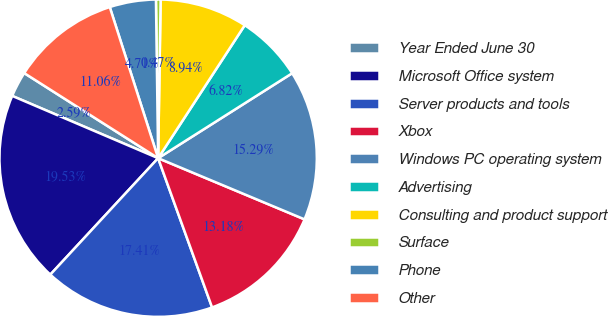<chart> <loc_0><loc_0><loc_500><loc_500><pie_chart><fcel>Year Ended June 30<fcel>Microsoft Office system<fcel>Server products and tools<fcel>Xbox<fcel>Windows PC operating system<fcel>Advertising<fcel>Consulting and product support<fcel>Surface<fcel>Phone<fcel>Other<nl><fcel>2.59%<fcel>19.53%<fcel>17.41%<fcel>13.18%<fcel>15.29%<fcel>6.82%<fcel>8.94%<fcel>0.47%<fcel>4.71%<fcel>11.06%<nl></chart> 